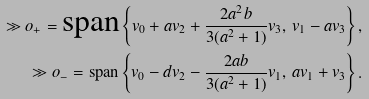Convert formula to latex. <formula><loc_0><loc_0><loc_500><loc_500>\gg o _ { + } = \text {span} \left \{ v _ { 0 } + a v _ { 2 } + \frac { 2 a ^ { 2 } b } { 3 ( a ^ { 2 } + 1 ) } v _ { 3 } , \, v _ { 1 } - a v _ { 3 } \right \} , \\ \gg o _ { - } = \text {span} \left \{ v _ { 0 } - d v _ { 2 } - \frac { 2 a b } { 3 ( a ^ { 2 } + 1 ) } v _ { 1 } , \, a v _ { 1 } + v _ { 3 } \right \} .</formula> 